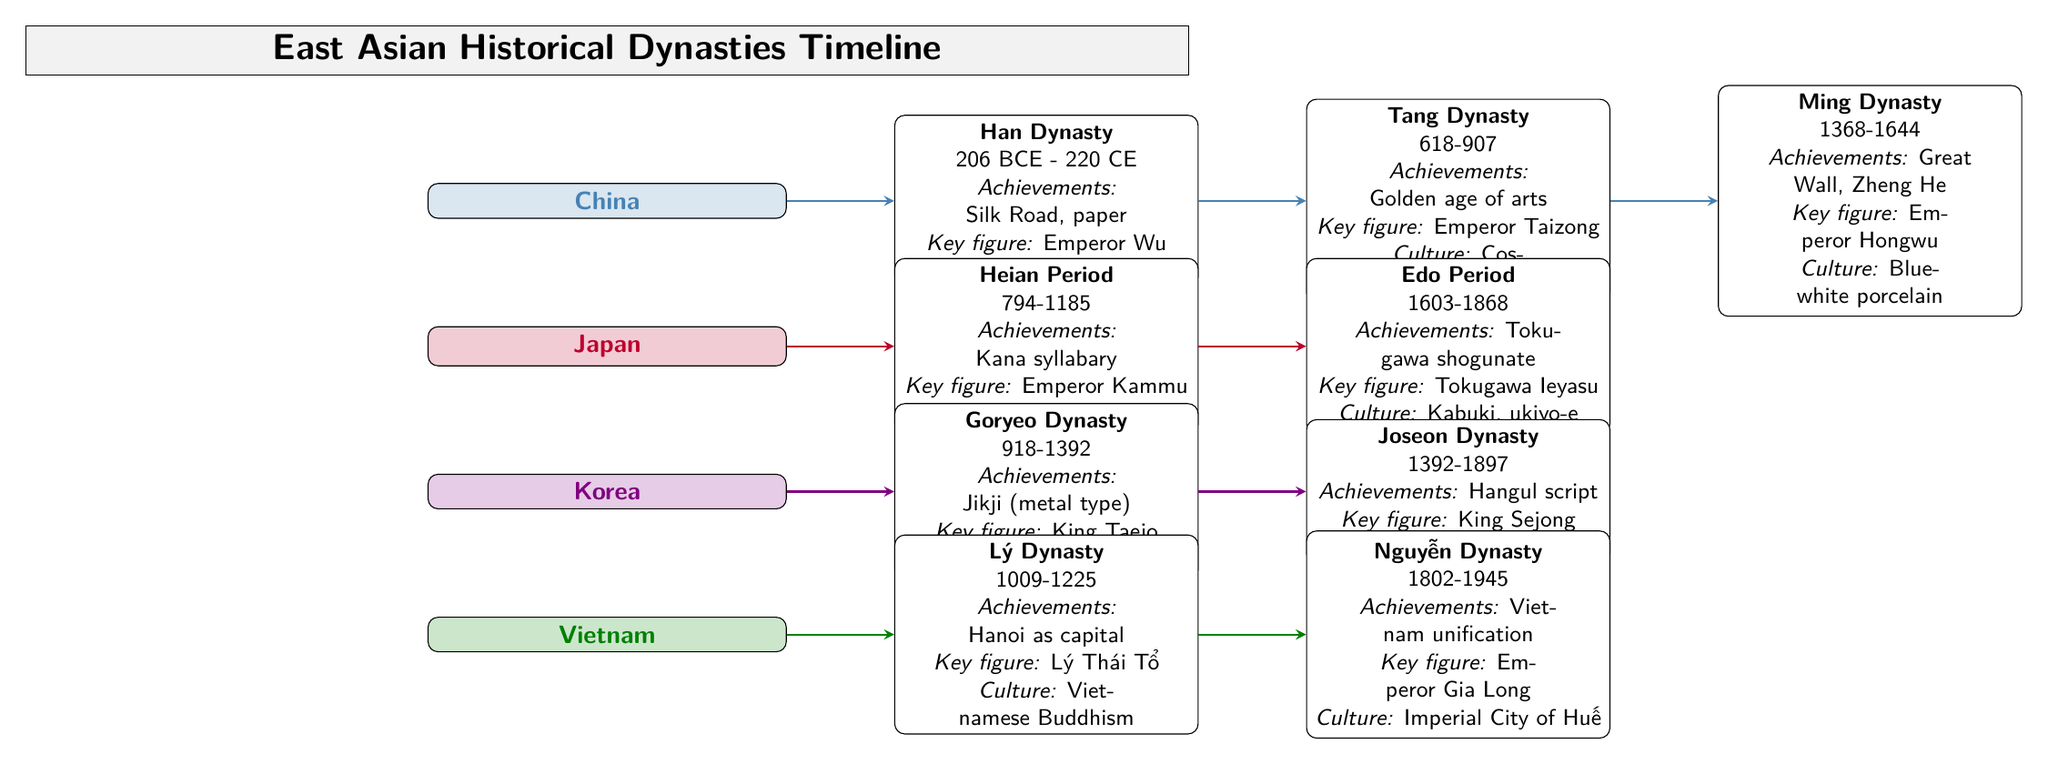What is the time span of the Tang Dynasty? The diagram states that the Tang Dynasty lasted from 618 to 907. To find the time span, we subtract the starting year from the ending year (907 - 618), which gives us a total duration of 289 years.
Answer: 289 years Who is the key figure associated with the Joseon Dynasty? Referring to the Joseon Dynasty section in the diagram, it specifically mentions King Sejong as the key figure. Therefore, the answer is directly taken from that information.
Answer: King Sejong What cultural contribution is linked to the Heian Period? The Heian Period is associated with the development of the Kana syllabary according to the diagram. By locating the Heian Period node, we can directly find this cultural achievement related to it.
Answer: Kana syllabary How many major dynasties are represented on the timeline? The diagram includes four countries, and each country has two dynasties listed, which total to eight major dynasties. Counting the dynasties across all four countries gives the number of nodes representing the dynasties.
Answer: Eight dynasties What achievement is highlighted under the Ming Dynasty? The diagram states that one of the achievements of the Ming Dynasty is the Great Wall and Zheng He. By locating the Ming Dynasty node and identifying the associated achievements, we arrive at this information.
Answer: Great Wall, Zheng He Which dynasty is known for introducing the Hangul script? The Joseon Dynasty is specifically noted in the diagram for its achievement of creating the Hangul script. By examining the Joseon Dynasty entry, we can derive this information clearly related to the script.
Answer: Joseon Dynasty What notable cultural aspect is associated with the Nguyễn Dynasty? The Nguyễn Dynasty is linked to the Imperial City of Huế as its notable cultural contribution according to the diagram. Referring to the Nguyễn Dynasty section allows us to pinpoint this cultural aspect directly.
Answer: Imperial City of Huế Which dynasty is situated after the Goryeo Dynasty in the diagram? The diagram indicates that the Joseon Dynasty follows the Goryeo Dynasty. By observing the arrows that connect the dynasties, we can trace the lineage and ascertain that Joseon comes next.
Answer: Joseon Dynasty What key figure is noted for the Lý Dynasty? The diagram identifies Lý Thái Tổ as the key figure of the Lý Dynasty. Checking the Lý Dynasty node reveals this important historical figure.
Answer: Lý Thái Tổ 